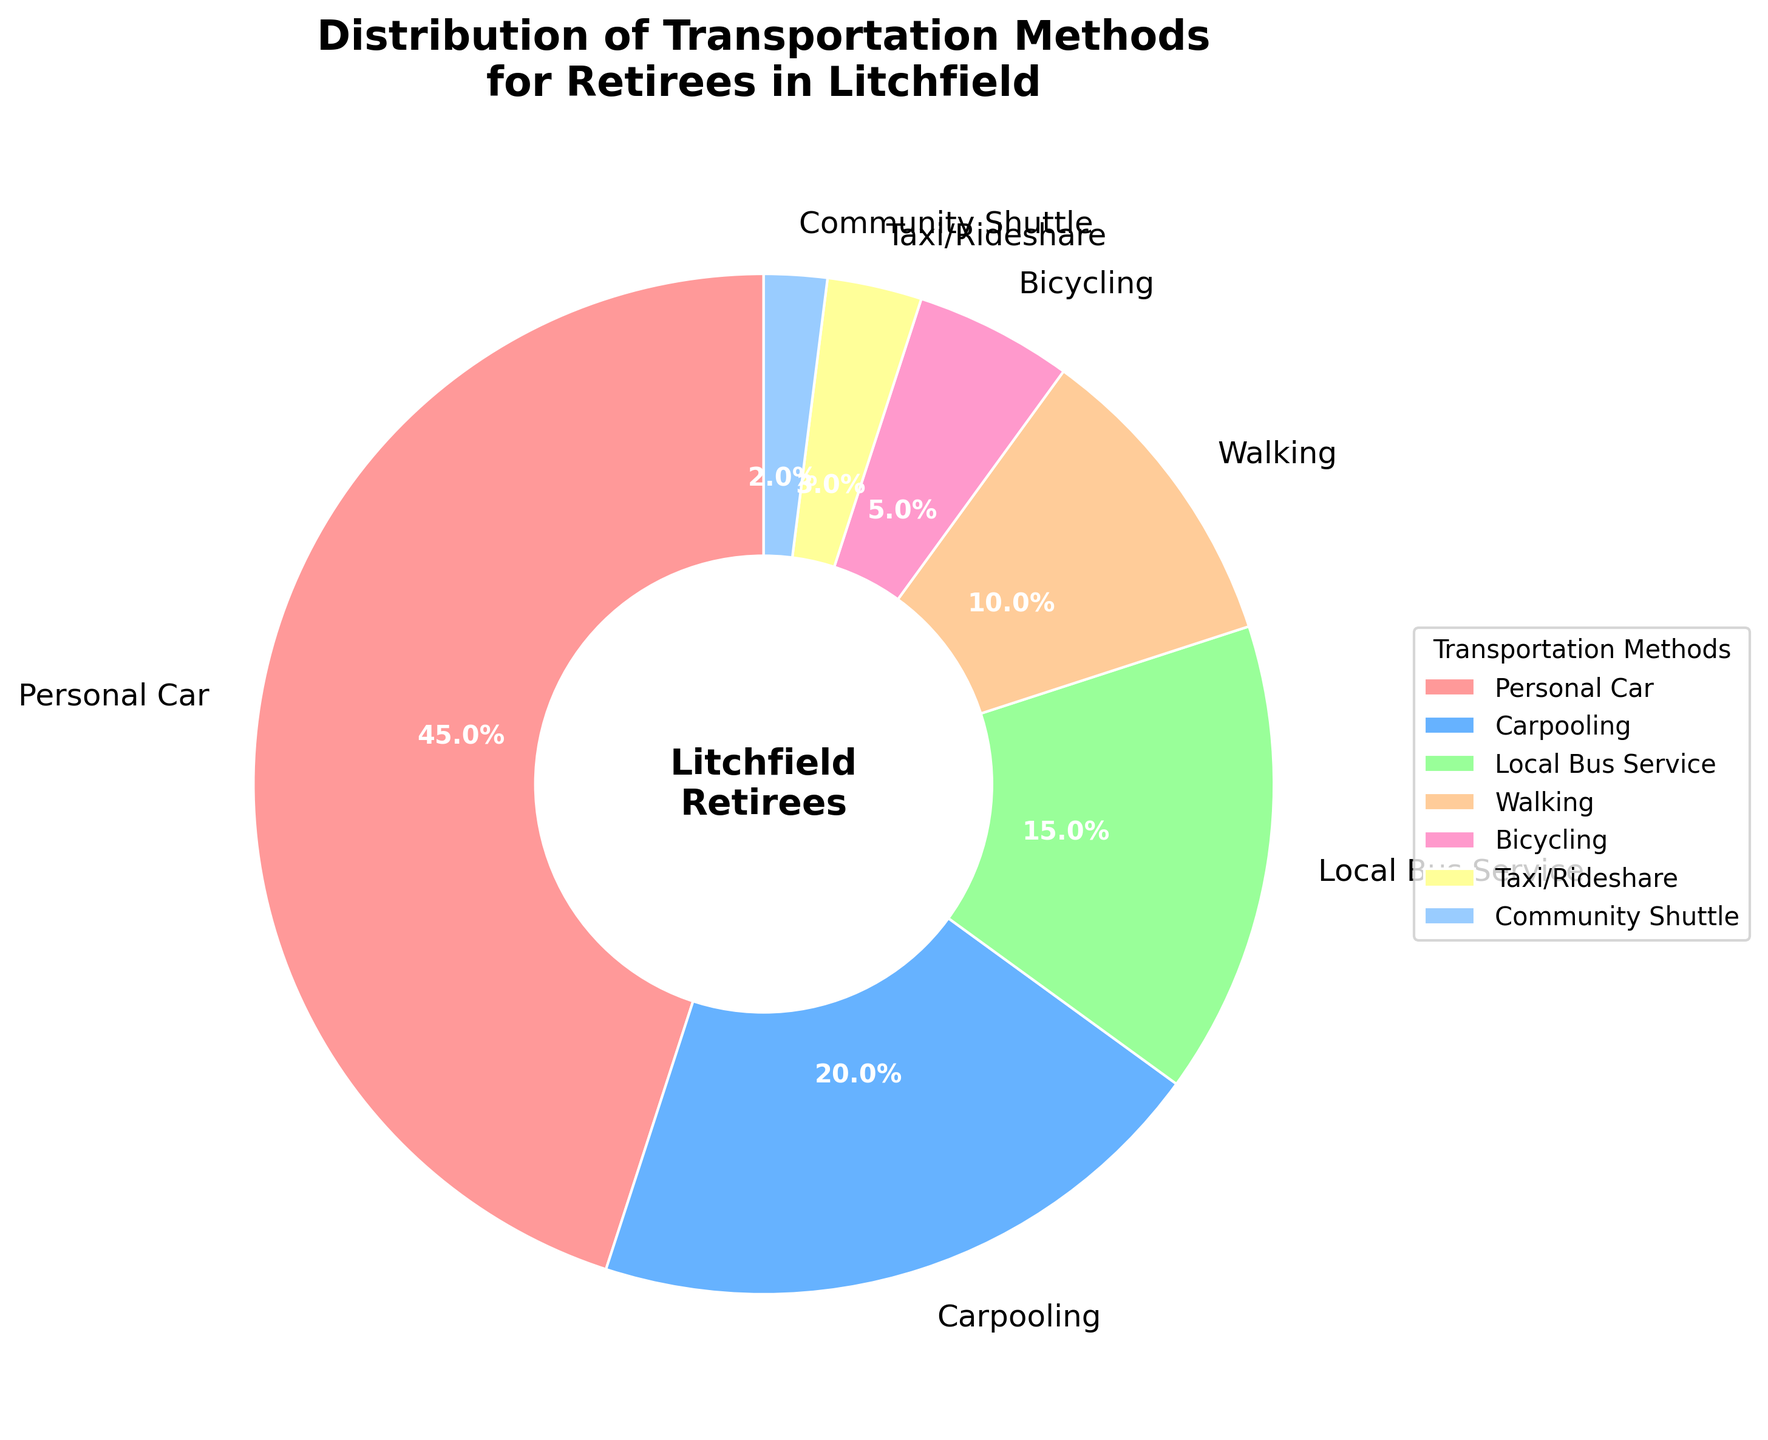What is the title of the figure? The title of the figure is prominently displayed at the top. It reads "Distribution of Transportation Methods for Retirees in Litchfield".
Answer: Distribution of Transportation Methods for Retirees in Litchfield How many transportation methods are displayed in the pie chart? The pie chart segments are labeled with different transportation methods. Counting them gives the total number of methods. There are 7 transportation methods displayed.
Answer: 7 What percentage of retirees use their personal car? The segment labeled as "Personal Car" has a percentage value listed on it. It states that 45% of retirees use their personal car.
Answer: 45% What transportation method has the lowest usage percentage among retirees? The smallest segment on the pie chart is labeled as "Community Shuttle", which has the lowest percentage.
Answer: Community Shuttle How does the usage of “Local Bus Service” compare to “Carpooling”? The "Local Bus Service" segment is labeled with 15%, and the "Carpooling" segment is labeled with 20%. Comparing these values shows that carpooling is used more than the local bus service.
Answer: Carpooling is used more What is the combined percentage of retirees who use Walking and Bicycling? The percentage for Walking is 10% and for Bicycling is 5%. Adding these two percentages gives the combined total: 10% + 5%.
Answer: 15% Which two transportation methods together constitute 25% of the usage among retirees? Looking for segments that together sum up to 25%. Carpooling is 20% and Taxi/Rideshare is 3%. The sum of these is not 25%, so we try Walking (10%) and Bicycling (5%), which gives 10% + 5% = 15% still not matching. Trying Local Bus Service (15%) and Walking (10%) gives us the correct sum, 15% + 10%.
Answer: Local Bus Service and Walking What is the percentage difference between the usage of Personal Car and Community Shuttle? Personal Car is 45% and Community Shuttle is 2%. The difference is calculated by subtracting the smaller percentage from the larger one: 45% - 2%.
Answer: 43% Which transportation method is preferred by less than 10% of retirees but more than 2%? We need to find segments whose labeled percentages are between 2% and 10%. The Taxi/Rideshare segment is labeled with 3%, which fits this range.
Answer: Taxi/Rideshare What is the percentage difference between the most and least used transportation methods? The most used method is Personal Car at 45% and the least used is Community Shuttle at 2%. Subtracting the smallest percentage from the largest gives us: 45% - 2%.
Answer: 43% 